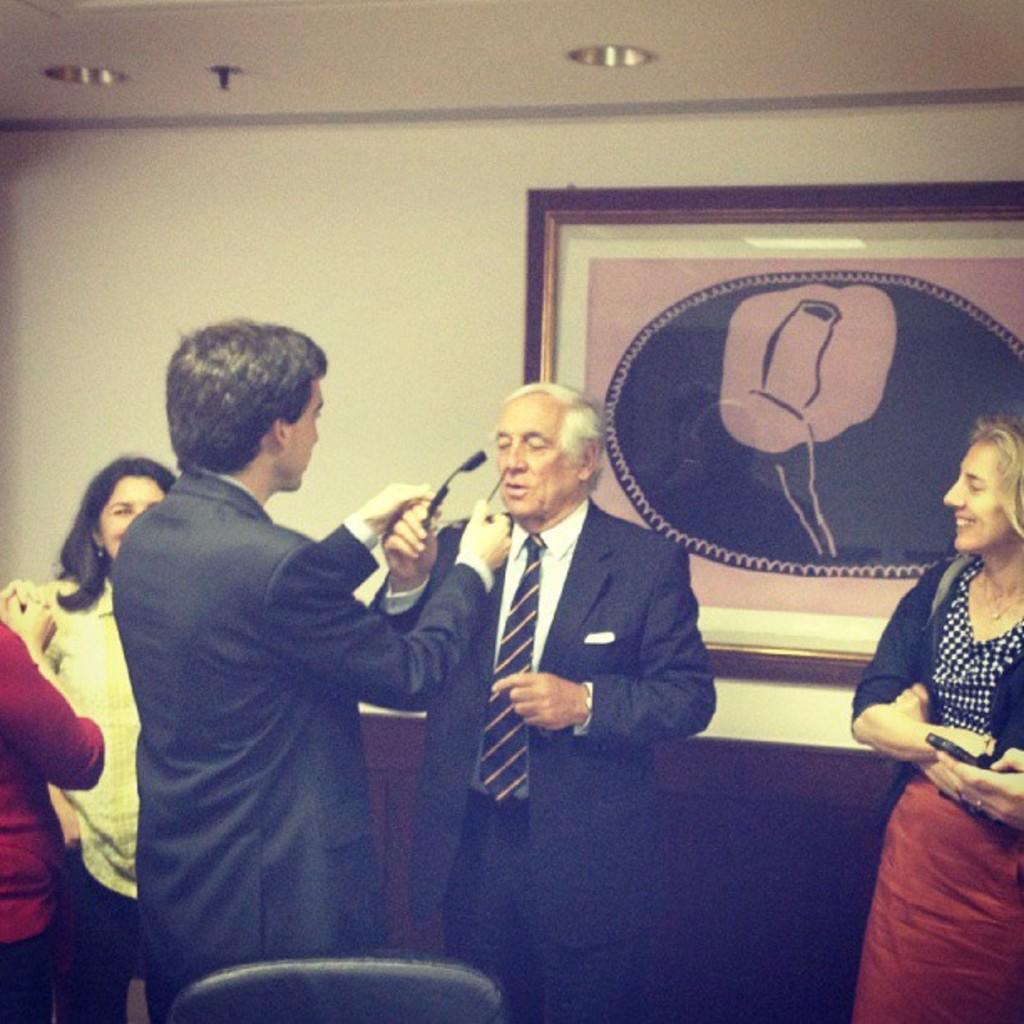Could you give a brief overview of what you see in this image? At the top we can see the ceiling and objects. In this picture we can see a frame on the wall. We can see the people. We can see the men are holding an object. On the right side of the picture we can see a woman is smiling. 